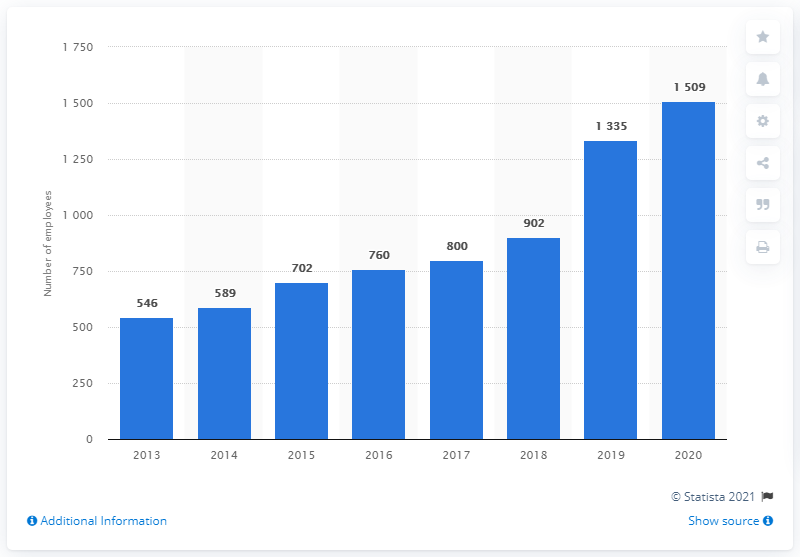Highlight a few significant elements in this photo. In 2013, Sobi had 546 employees. 